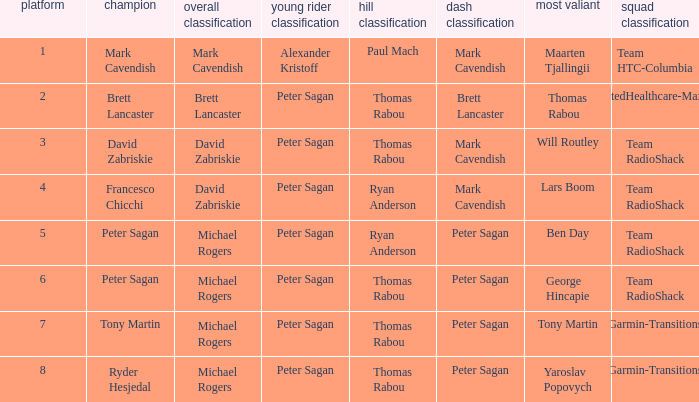Who won the mountains classification when Maarten Tjallingii won most corageous? Paul Mach. 